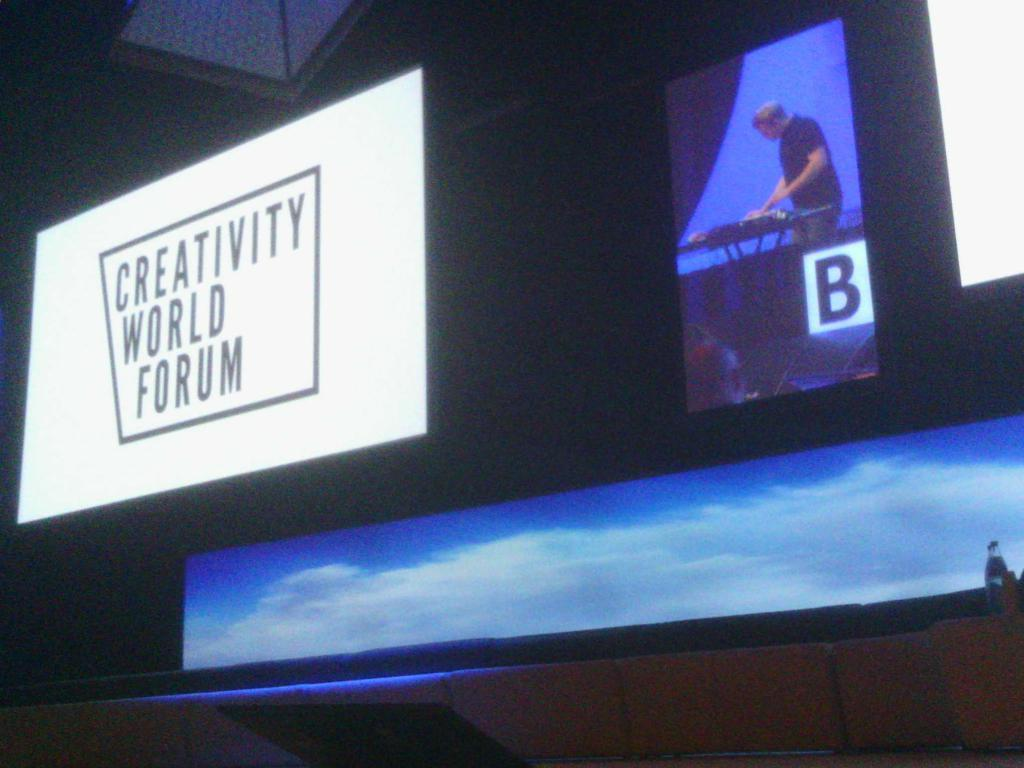<image>
Create a compact narrative representing the image presented. A display of a man messing about with something on a table next to a white disply for the Creativity World Forum. 